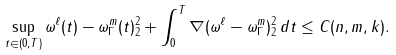<formula> <loc_0><loc_0><loc_500><loc_500>\sup _ { t \in ( 0 , T ) } \| \omega ^ { \ell } ( t ) - \omega _ { \Gamma } ^ { m } ( t ) \| _ { 2 } ^ { 2 } + \int _ { 0 } ^ { T } \| \nabla ( \omega ^ { \ell } - \omega _ { \Gamma } ^ { m } ) \| _ { 2 } ^ { 2 } \, d t \leq C ( n , m , k ) .</formula> 